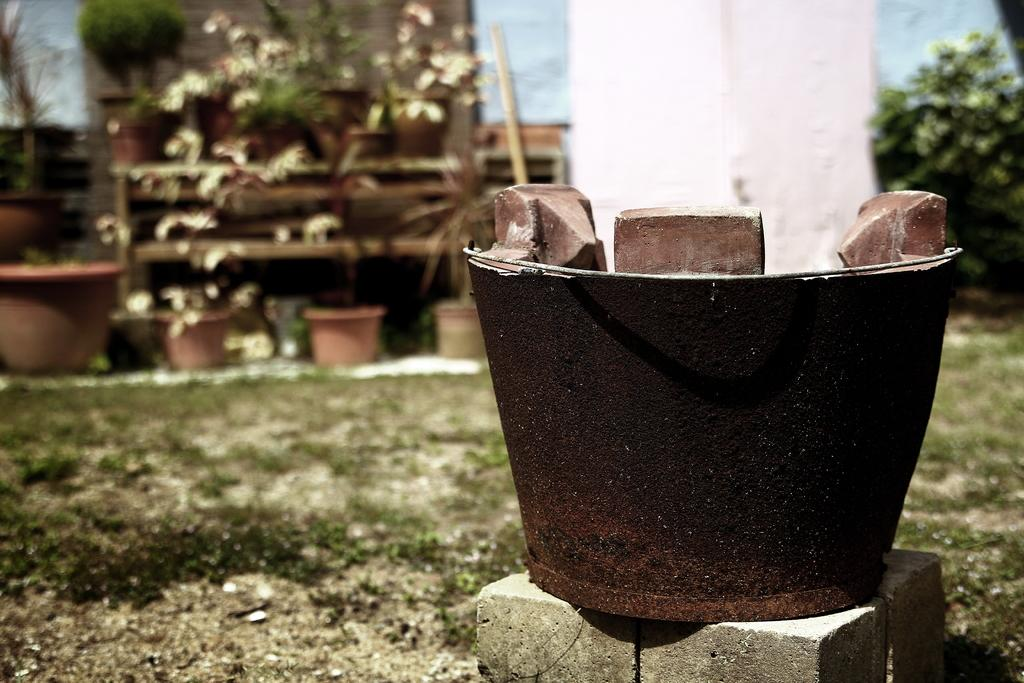What type of structures can be seen in the image? There are buildings in the image. What other elements are present in the image besides buildings? There are plants and pots in the image. What is visible in the front of the image? There is ground and grass in the front of the image. How would you describe the background of the image? The background of the image is slightly blurred. What type of spark can be seen coming from the plants in the image? There is no spark present in the image; the plants are not emitting any sparks. 